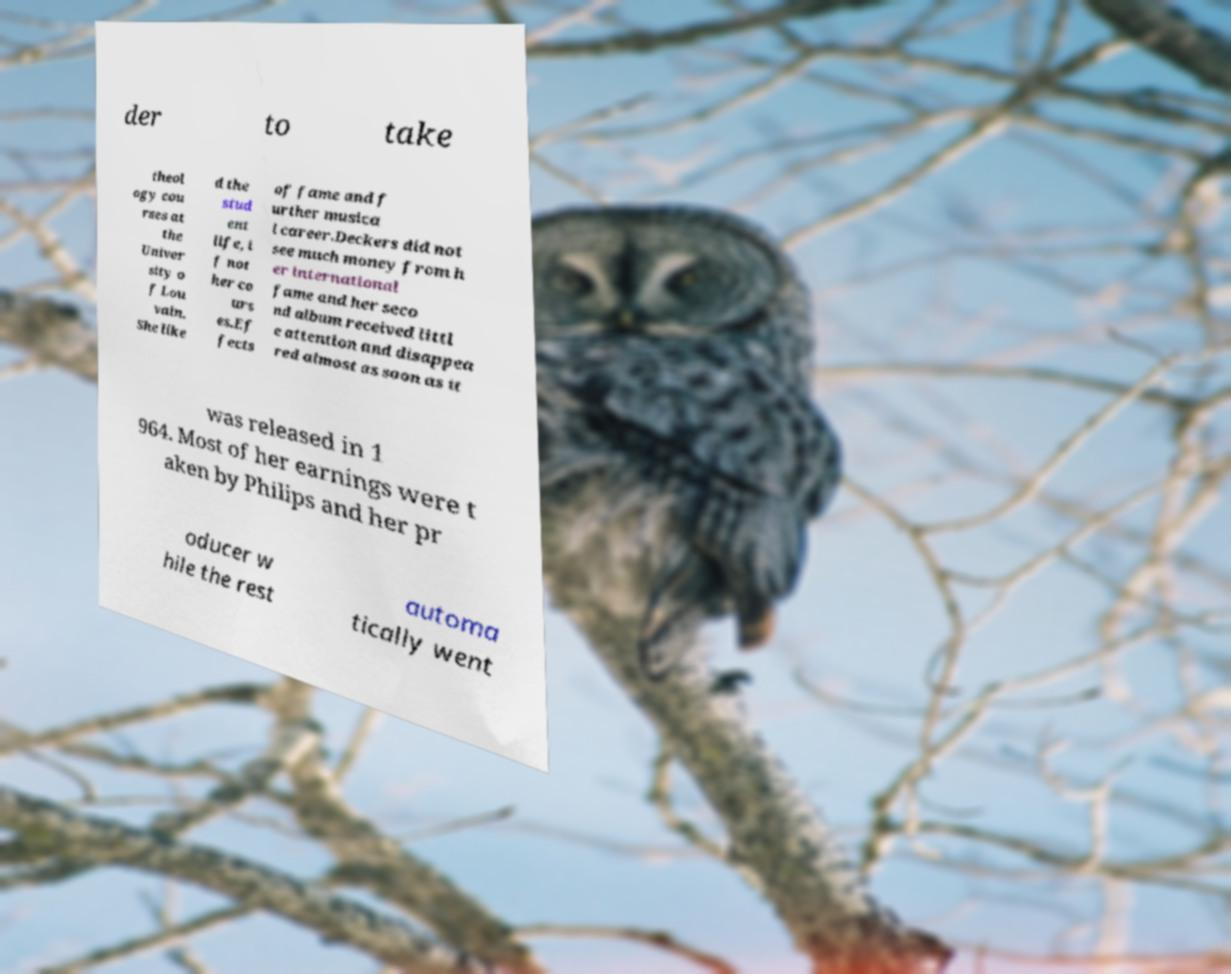Please read and relay the text visible in this image. What does it say? der to take theol ogy cou rses at the Univer sity o f Lou vain. She like d the stud ent life, i f not her co urs es.Ef fects of fame and f urther musica l career.Deckers did not see much money from h er international fame and her seco nd album received littl e attention and disappea red almost as soon as it was released in 1 964. Most of her earnings were t aken by Philips and her pr oducer w hile the rest automa tically went 